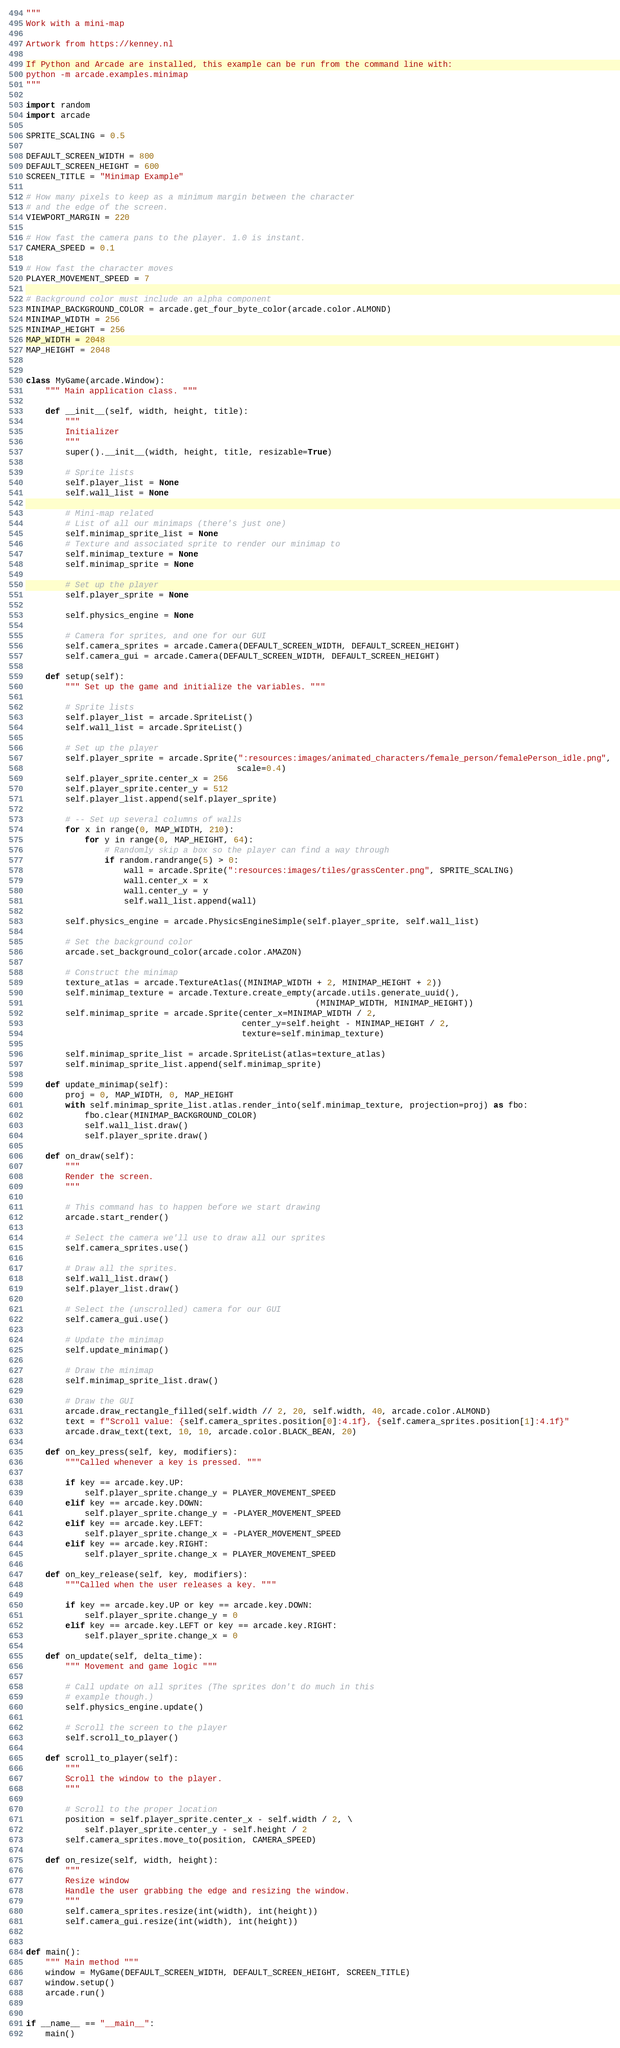Convert code to text. <code><loc_0><loc_0><loc_500><loc_500><_Python_>"""
Work with a mini-map

Artwork from https://kenney.nl

If Python and Arcade are installed, this example can be run from the command line with:
python -m arcade.examples.minimap
"""

import random
import arcade

SPRITE_SCALING = 0.5

DEFAULT_SCREEN_WIDTH = 800
DEFAULT_SCREEN_HEIGHT = 600
SCREEN_TITLE = "Minimap Example"

# How many pixels to keep as a minimum margin between the character
# and the edge of the screen.
VIEWPORT_MARGIN = 220

# How fast the camera pans to the player. 1.0 is instant.
CAMERA_SPEED = 0.1

# How fast the character moves
PLAYER_MOVEMENT_SPEED = 7

# Background color must include an alpha component
MINIMAP_BACKGROUND_COLOR = arcade.get_four_byte_color(arcade.color.ALMOND)
MINIMAP_WIDTH = 256
MINIMAP_HEIGHT = 256
MAP_WIDTH = 2048
MAP_HEIGHT = 2048


class MyGame(arcade.Window):
    """ Main application class. """

    def __init__(self, width, height, title):
        """
        Initializer
        """
        super().__init__(width, height, title, resizable=True)

        # Sprite lists
        self.player_list = None
        self.wall_list = None

        # Mini-map related
        # List of all our minimaps (there's just one)
        self.minimap_sprite_list = None
        # Texture and associated sprite to render our minimap to
        self.minimap_texture = None
        self.minimap_sprite = None

        # Set up the player
        self.player_sprite = None

        self.physics_engine = None

        # Camera for sprites, and one for our GUI
        self.camera_sprites = arcade.Camera(DEFAULT_SCREEN_WIDTH, DEFAULT_SCREEN_HEIGHT)
        self.camera_gui = arcade.Camera(DEFAULT_SCREEN_WIDTH, DEFAULT_SCREEN_HEIGHT)

    def setup(self):
        """ Set up the game and initialize the variables. """

        # Sprite lists
        self.player_list = arcade.SpriteList()
        self.wall_list = arcade.SpriteList()

        # Set up the player
        self.player_sprite = arcade.Sprite(":resources:images/animated_characters/female_person/femalePerson_idle.png",
                                           scale=0.4)
        self.player_sprite.center_x = 256
        self.player_sprite.center_y = 512
        self.player_list.append(self.player_sprite)

        # -- Set up several columns of walls
        for x in range(0, MAP_WIDTH, 210):
            for y in range(0, MAP_HEIGHT, 64):
                # Randomly skip a box so the player can find a way through
                if random.randrange(5) > 0:
                    wall = arcade.Sprite(":resources:images/tiles/grassCenter.png", SPRITE_SCALING)
                    wall.center_x = x
                    wall.center_y = y
                    self.wall_list.append(wall)

        self.physics_engine = arcade.PhysicsEngineSimple(self.player_sprite, self.wall_list)

        # Set the background color
        arcade.set_background_color(arcade.color.AMAZON)

        # Construct the minimap
        texture_atlas = arcade.TextureAtlas((MINIMAP_WIDTH + 2, MINIMAP_HEIGHT + 2))
        self.minimap_texture = arcade.Texture.create_empty(arcade.utils.generate_uuid(),
                                                           (MINIMAP_WIDTH, MINIMAP_HEIGHT))
        self.minimap_sprite = arcade.Sprite(center_x=MINIMAP_WIDTH / 2,
                                            center_y=self.height - MINIMAP_HEIGHT / 2,
                                            texture=self.minimap_texture)

        self.minimap_sprite_list = arcade.SpriteList(atlas=texture_atlas)
        self.minimap_sprite_list.append(self.minimap_sprite)

    def update_minimap(self):
        proj = 0, MAP_WIDTH, 0, MAP_HEIGHT
        with self.minimap_sprite_list.atlas.render_into(self.minimap_texture, projection=proj) as fbo:
            fbo.clear(MINIMAP_BACKGROUND_COLOR)
            self.wall_list.draw()
            self.player_sprite.draw()

    def on_draw(self):
        """
        Render the screen.
        """

        # This command has to happen before we start drawing
        arcade.start_render()

        # Select the camera we'll use to draw all our sprites
        self.camera_sprites.use()

        # Draw all the sprites.
        self.wall_list.draw()
        self.player_list.draw()

        # Select the (unscrolled) camera for our GUI
        self.camera_gui.use()

        # Update the minimap
        self.update_minimap()

        # Draw the minimap
        self.minimap_sprite_list.draw()

        # Draw the GUI
        arcade.draw_rectangle_filled(self.width // 2, 20, self.width, 40, arcade.color.ALMOND)
        text = f"Scroll value: {self.camera_sprites.position[0]:4.1f}, {self.camera_sprites.position[1]:4.1f}"
        arcade.draw_text(text, 10, 10, arcade.color.BLACK_BEAN, 20)

    def on_key_press(self, key, modifiers):
        """Called whenever a key is pressed. """

        if key == arcade.key.UP:
            self.player_sprite.change_y = PLAYER_MOVEMENT_SPEED
        elif key == arcade.key.DOWN:
            self.player_sprite.change_y = -PLAYER_MOVEMENT_SPEED
        elif key == arcade.key.LEFT:
            self.player_sprite.change_x = -PLAYER_MOVEMENT_SPEED
        elif key == arcade.key.RIGHT:
            self.player_sprite.change_x = PLAYER_MOVEMENT_SPEED

    def on_key_release(self, key, modifiers):
        """Called when the user releases a key. """

        if key == arcade.key.UP or key == arcade.key.DOWN:
            self.player_sprite.change_y = 0
        elif key == arcade.key.LEFT or key == arcade.key.RIGHT:
            self.player_sprite.change_x = 0

    def on_update(self, delta_time):
        """ Movement and game logic """

        # Call update on all sprites (The sprites don't do much in this
        # example though.)
        self.physics_engine.update()

        # Scroll the screen to the player
        self.scroll_to_player()

    def scroll_to_player(self):
        """
        Scroll the window to the player.
        """

        # Scroll to the proper location
        position = self.player_sprite.center_x - self.width / 2, \
            self.player_sprite.center_y - self.height / 2
        self.camera_sprites.move_to(position, CAMERA_SPEED)

    def on_resize(self, width, height):
        """
        Resize window
        Handle the user grabbing the edge and resizing the window.
        """
        self.camera_sprites.resize(int(width), int(height))
        self.camera_gui.resize(int(width), int(height))


def main():
    """ Main method """
    window = MyGame(DEFAULT_SCREEN_WIDTH, DEFAULT_SCREEN_HEIGHT, SCREEN_TITLE)
    window.setup()
    arcade.run()


if __name__ == "__main__":
    main()
</code> 